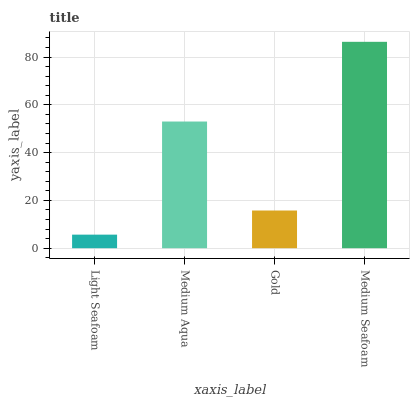Is Light Seafoam the minimum?
Answer yes or no. Yes. Is Medium Seafoam the maximum?
Answer yes or no. Yes. Is Medium Aqua the minimum?
Answer yes or no. No. Is Medium Aqua the maximum?
Answer yes or no. No. Is Medium Aqua greater than Light Seafoam?
Answer yes or no. Yes. Is Light Seafoam less than Medium Aqua?
Answer yes or no. Yes. Is Light Seafoam greater than Medium Aqua?
Answer yes or no. No. Is Medium Aqua less than Light Seafoam?
Answer yes or no. No. Is Medium Aqua the high median?
Answer yes or no. Yes. Is Gold the low median?
Answer yes or no. Yes. Is Gold the high median?
Answer yes or no. No. Is Medium Aqua the low median?
Answer yes or no. No. 